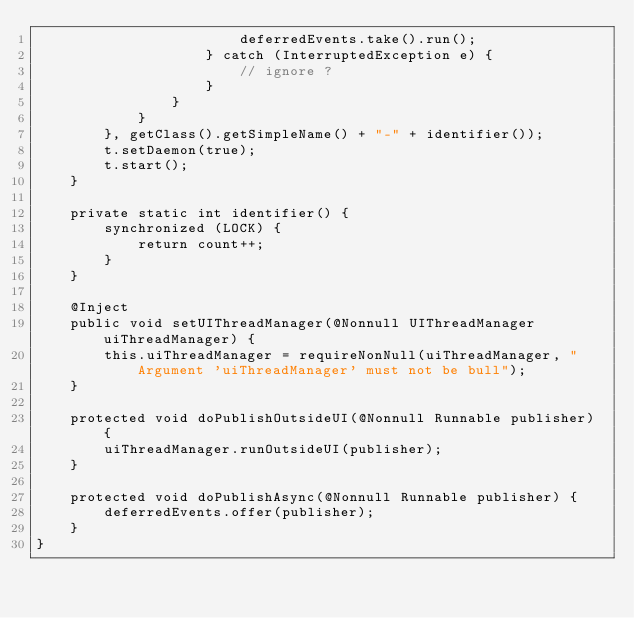<code> <loc_0><loc_0><loc_500><loc_500><_Java_>                        deferredEvents.take().run();
                    } catch (InterruptedException e) {
                        // ignore ?
                    }
                }
            }
        }, getClass().getSimpleName() + "-" + identifier());
        t.setDaemon(true);
        t.start();
    }

    private static int identifier() {
        synchronized (LOCK) {
            return count++;
        }
    }

    @Inject
    public void setUIThreadManager(@Nonnull UIThreadManager uiThreadManager) {
        this.uiThreadManager = requireNonNull(uiThreadManager, "Argument 'uiThreadManager' must not be bull");
    }

    protected void doPublishOutsideUI(@Nonnull Runnable publisher) {
        uiThreadManager.runOutsideUI(publisher);
    }

    protected void doPublishAsync(@Nonnull Runnable publisher) {
        deferredEvents.offer(publisher);
    }
}
</code> 